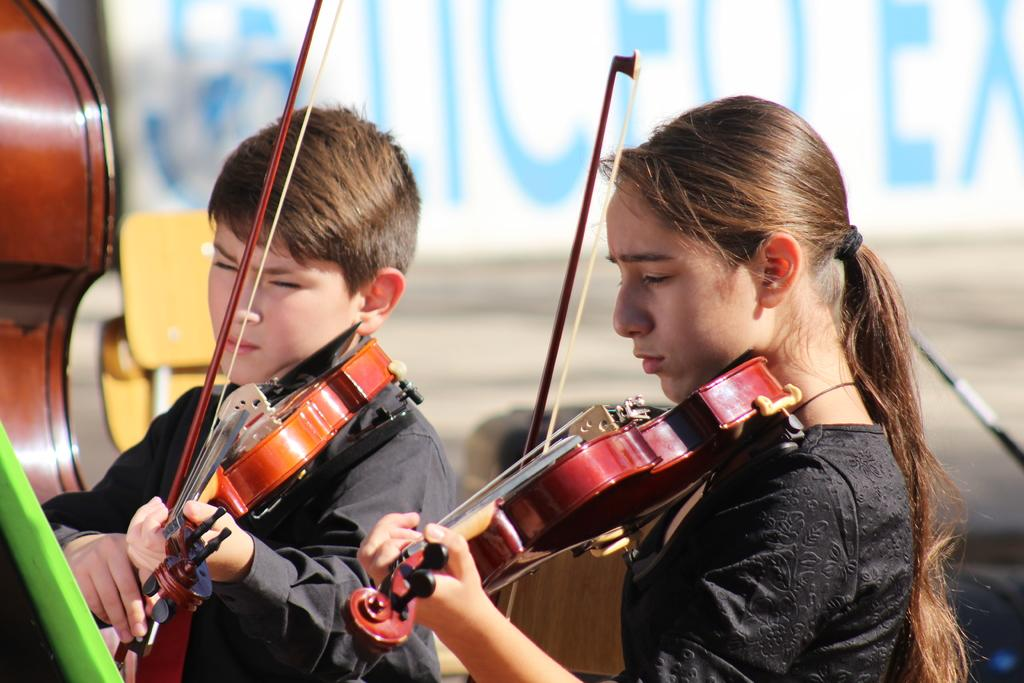Who are the people in the image? There is a girl and a boy in the image. What are the girl and boy doing in the image? Both the girl and boy are playing the violin. What can be seen in the background of the image? There is a banner and a road in the background of the image. What type of agreement is depicted on the banner in the image? There is no agreement depicted on the banner in the image; it is not mentioned in the provided facts. How many pizzas are being delivered on the road in the background of the image? There is no mention of pizzas or delivery in the image or the provided facts. 